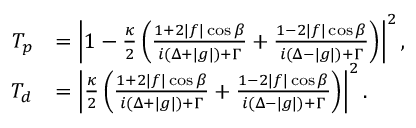<formula> <loc_0><loc_0><loc_500><loc_500>\begin{array} { r l } { T _ { p } } & { = \left | 1 - \frac { \kappa } { 2 } \left ( \frac { 1 + 2 | f | \cos \beta } { i ( \Delta + | g | ) + \Gamma } + \frac { 1 - 2 | f | \cos \beta } { i ( \Delta - | g | ) + \Gamma } \right ) \right | ^ { 2 } , } \\ { T _ { d } } & { = \left | \frac { \kappa } { 2 } \left ( \frac { 1 + 2 | f | \cos \beta } { i ( \Delta + | g | ) + \Gamma } + \frac { 1 - 2 | f | \cos \beta } { i ( \Delta - | g | ) + \Gamma } \right ) \right | ^ { 2 } . } \end{array}</formula> 